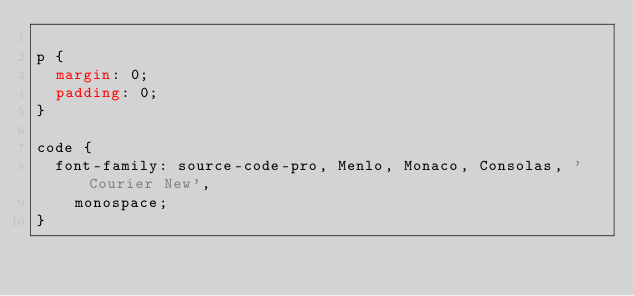Convert code to text. <code><loc_0><loc_0><loc_500><loc_500><_CSS_>
p {
  margin: 0;
  padding: 0;
}

code {
  font-family: source-code-pro, Menlo, Monaco, Consolas, 'Courier New',
    monospace;
}
</code> 